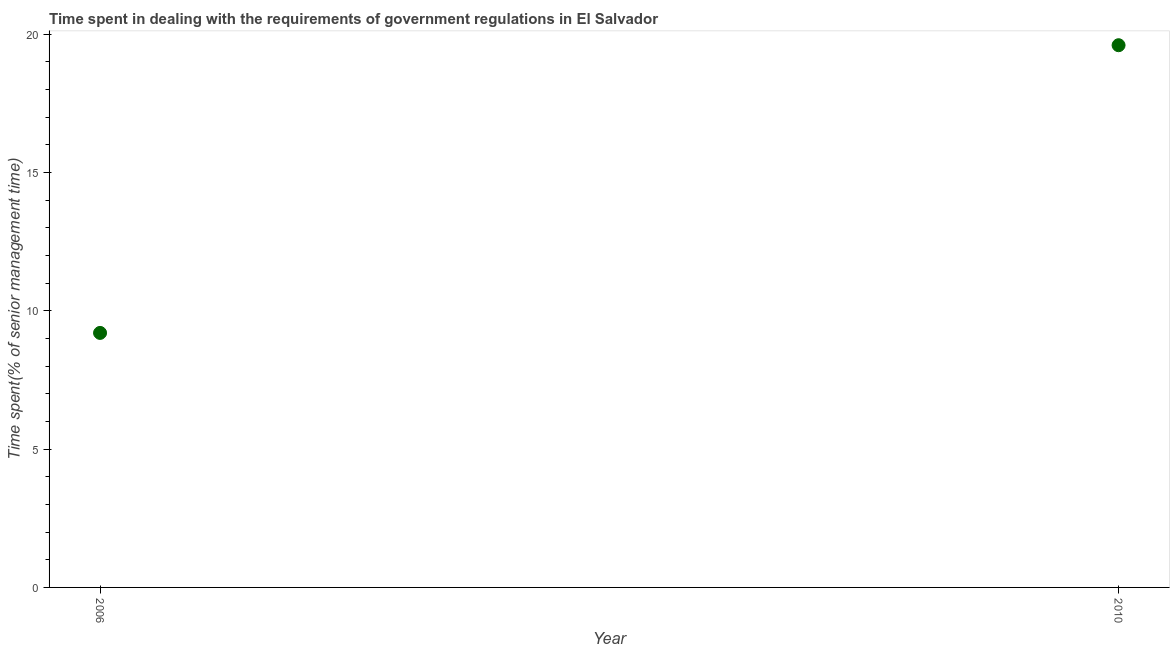What is the time spent in dealing with government regulations in 2010?
Ensure brevity in your answer.  19.6. Across all years, what is the maximum time spent in dealing with government regulations?
Provide a short and direct response. 19.6. In which year was the time spent in dealing with government regulations maximum?
Offer a very short reply. 2010. In which year was the time spent in dealing with government regulations minimum?
Offer a terse response. 2006. What is the sum of the time spent in dealing with government regulations?
Offer a terse response. 28.8. What is the difference between the time spent in dealing with government regulations in 2006 and 2010?
Make the answer very short. -10.4. What is the median time spent in dealing with government regulations?
Your response must be concise. 14.4. In how many years, is the time spent in dealing with government regulations greater than 17 %?
Your answer should be very brief. 1. Do a majority of the years between 2006 and 2010 (inclusive) have time spent in dealing with government regulations greater than 1 %?
Your answer should be very brief. Yes. What is the ratio of the time spent in dealing with government regulations in 2006 to that in 2010?
Your response must be concise. 0.47. Is the time spent in dealing with government regulations in 2006 less than that in 2010?
Your response must be concise. Yes. How many dotlines are there?
Offer a terse response. 1. Are the values on the major ticks of Y-axis written in scientific E-notation?
Ensure brevity in your answer.  No. Does the graph contain any zero values?
Offer a very short reply. No. Does the graph contain grids?
Offer a very short reply. No. What is the title of the graph?
Your answer should be very brief. Time spent in dealing with the requirements of government regulations in El Salvador. What is the label or title of the Y-axis?
Give a very brief answer. Time spent(% of senior management time). What is the Time spent(% of senior management time) in 2006?
Offer a very short reply. 9.2. What is the Time spent(% of senior management time) in 2010?
Offer a very short reply. 19.6. What is the ratio of the Time spent(% of senior management time) in 2006 to that in 2010?
Ensure brevity in your answer.  0.47. 